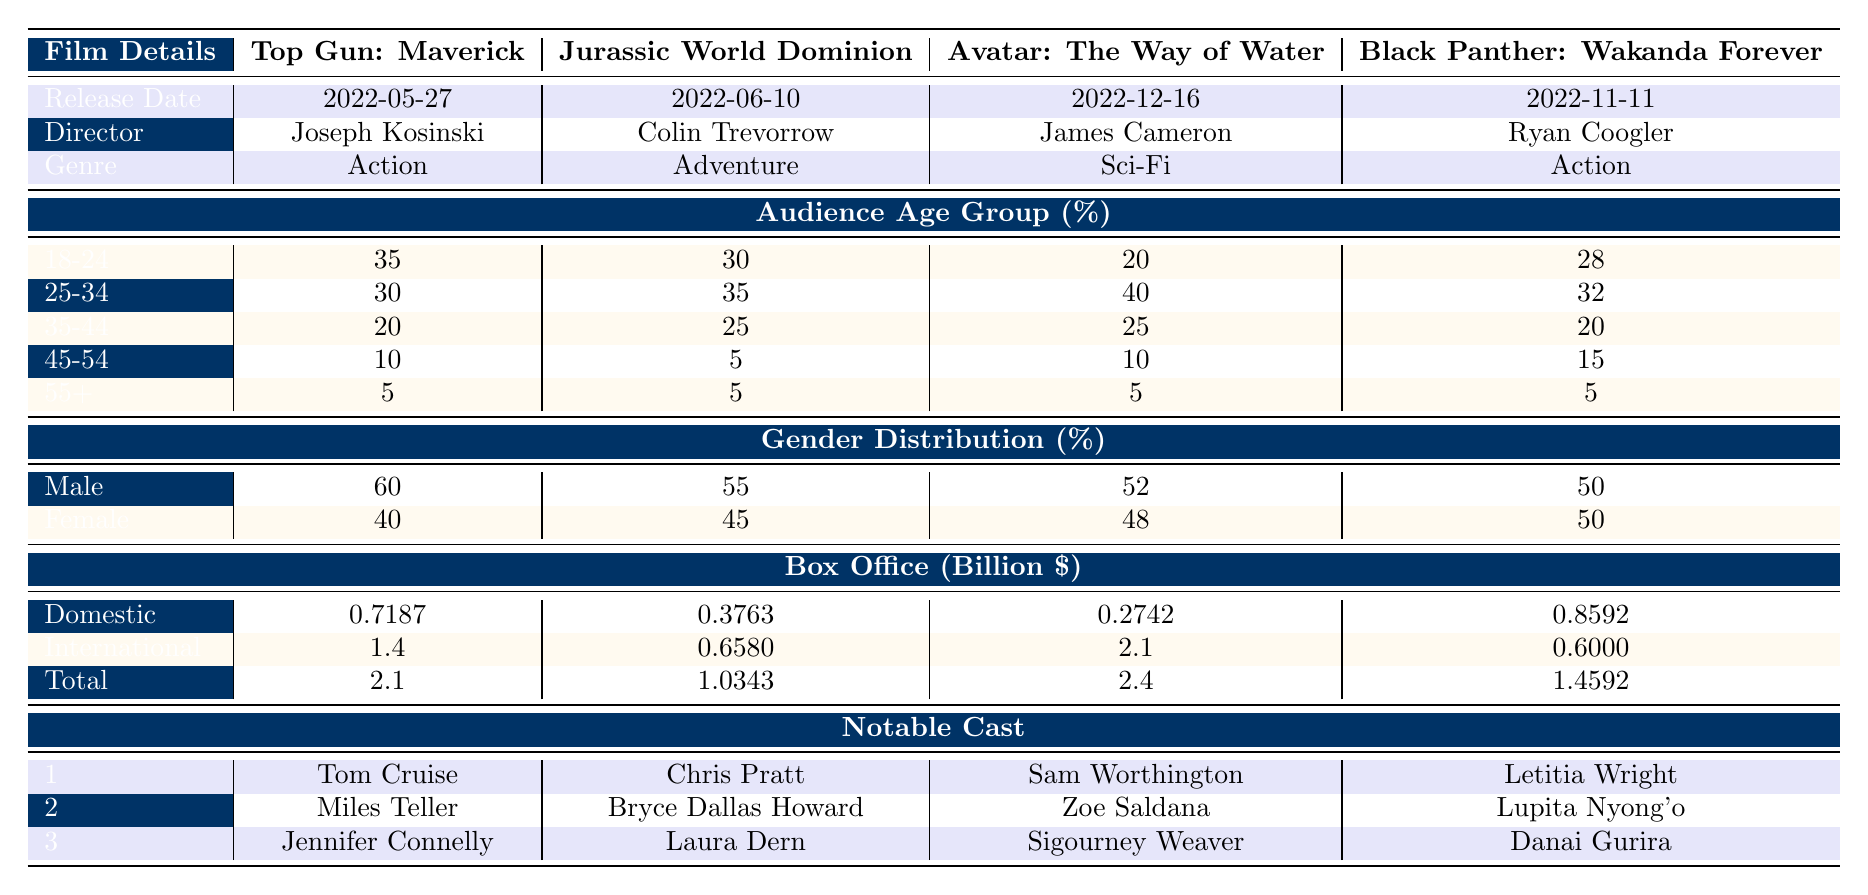What is the release date of "Avatar: The Way of Water"? The table shows the release dates for each film, and for "Avatar: The Way of Water," it is listed as 2022-12-16.
Answer: 2022-12-16 Which film had the highest domestic box office earnings? By comparing the domestic earnings listed, "Black Panther: Wakanda Forever" has the highest domestic earnings at 859.2 million dollars.
Answer: Black Panther: Wakanda Forever What percentage of the audience for "Jurassic World Dominion" was aged 25-34? The table shows that for "Jurassic World Dominion," the percentage of the audience in the 25-34 age group is 35%.
Answer: 35% Is the gender distribution for "Black Panther: Wakanda Forever" equal between male and female? The table indicates that the gender distribution for "Black Panther: Wakanda Forever" is 50% male and 50% female, which means it is equal.
Answer: Yes What is the total box office amount for "Top Gun: Maverick"? The total box office for "Top Gun: Maverick" is found in the table under total earnings, which is 2.1 billion dollars.
Answer: 2.1 billion dollars What is the average box office total for the films listed? To find the average, sum the total box office amounts: (2.1 + 1.0343 + 2.4 + 1.4592) = 6.9935 billion dollars. Then divide by 4 (the number of films): 6.9935/4 = 1.748375 billion dollars, which rounds to about 1.75 billion dollars.
Answer: 1.75 billion dollars How many notable cast members are listed for "Jurassic World Dominion"? The table states that "Jurassic World Dominion" features three notable cast members: Chris Pratt, Bryce Dallas Howard, and Laura Dern.
Answer: 3 Which film has the highest percentage of male viewers aged 18-24? The age group 18-24 is considered for each film, and "Top Gun: Maverick" has the highest percentage of viewers in this age group at 35%.
Answer: Top Gun: Maverick What is the difference in total box office earnings between "Avatar: The Way of Water" and "Jurassic World Dominion"? The total box office for "Avatar: The Way of Water" is 2.4 billion dollars and for "Jurassic World Dominion" it is 1.0343 billion dollars. The difference is calculated as 2.4 - 1.0343 = 1.3657 billion dollars.
Answer: 1.3657 billion dollars Does "Top Gun: Maverick" have more female viewers compared to "Avatar: The Way of Water"? The gender distribution shows that "Top Gun: Maverick" has 40% female viewers while "Avatar: The Way of Water" has 48% female viewers, indicating that "Top Gun: Maverick" has fewer female viewers.
Answer: No 